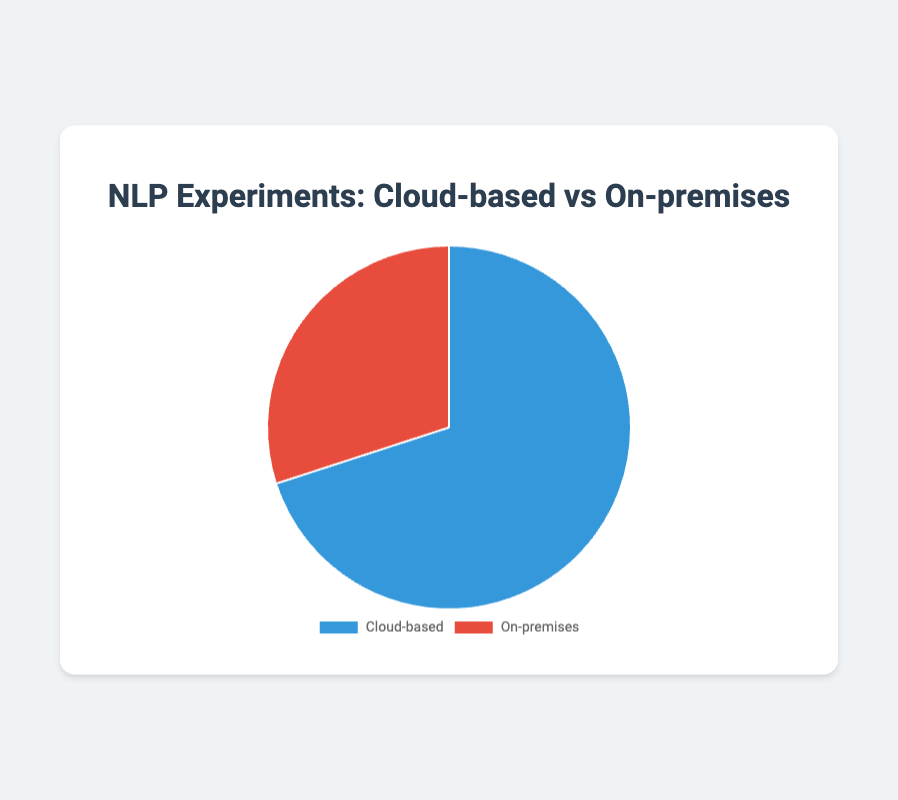What percentage of NLP experiments are cloud-based? The pie chart directly shows that 70% of NLP experiments use cloud-based computing resources. This is indicated by the blue section labeled 'Cloud-based'.
Answer: 70% What percentage of NLP experiments are on-premises? The pie chart indicates that 30% of NLP experiments use on-premises computing resources. This is visualized by the red section labeled 'On-premises'.
Answer: 30% Which type of computing resource is used more for NLP experiments? The chart shows that the cloud-based computing resource has a larger section (blue) compared to the on-premises section (red), indicating that cloud-based resources are used more.
Answer: Cloud-based What is the ratio of cloud-based to on-premises computing resources used for NLP experiments? The chart provides the percentages: 70% for cloud-based and 30% for on-premises. The ratio is 70:30, which can be simplified to 7:3.
Answer: 7:3 How much more common are cloud-based resources compared to on-premises? Cloud-based resources make up 70% while on-premises make up 30%. The difference is 70% - 30%, which shows cloud-based resources are 40% more common.
Answer: 40% If 100 NLP experiments were conducted, how many would be using on-premises resources? Given 30% of NLP experiments use on-premises resources, 30% of 100 is 30. So, 30 out of 100 experiments would use on-premises resources.
Answer: 30 What is the difference in percentage between cloud-based and on-premises computing resources used for NLP experiments? Cloud-based resources are 70% and on-premises are 30%. The difference is 70% - 30% = 40%.
Answer: 40% If an organization used 40% on-premises resources for NLP experiments, would it be higher or lower than the average use of on-premises resources? The average on-premises resource usage shown on the pie chart is 30%. 40% is higher than 30%.
Answer: Higher What color represents the cloud-based computing resources in the pie chart? The pie chart uses colors to differentiate between the types. The cloud-based section is represented by the blue color.
Answer: Blue 